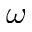<formula> <loc_0><loc_0><loc_500><loc_500>\omega</formula> 